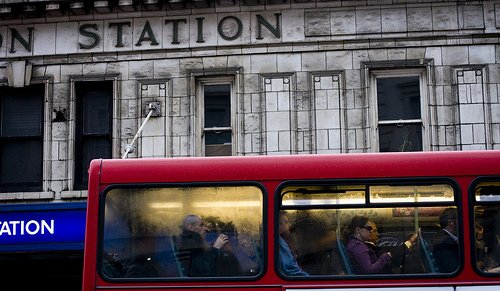<image>
Is there a woman behind the man? No. The woman is not behind the man. From this viewpoint, the woman appears to be positioned elsewhere in the scene. 